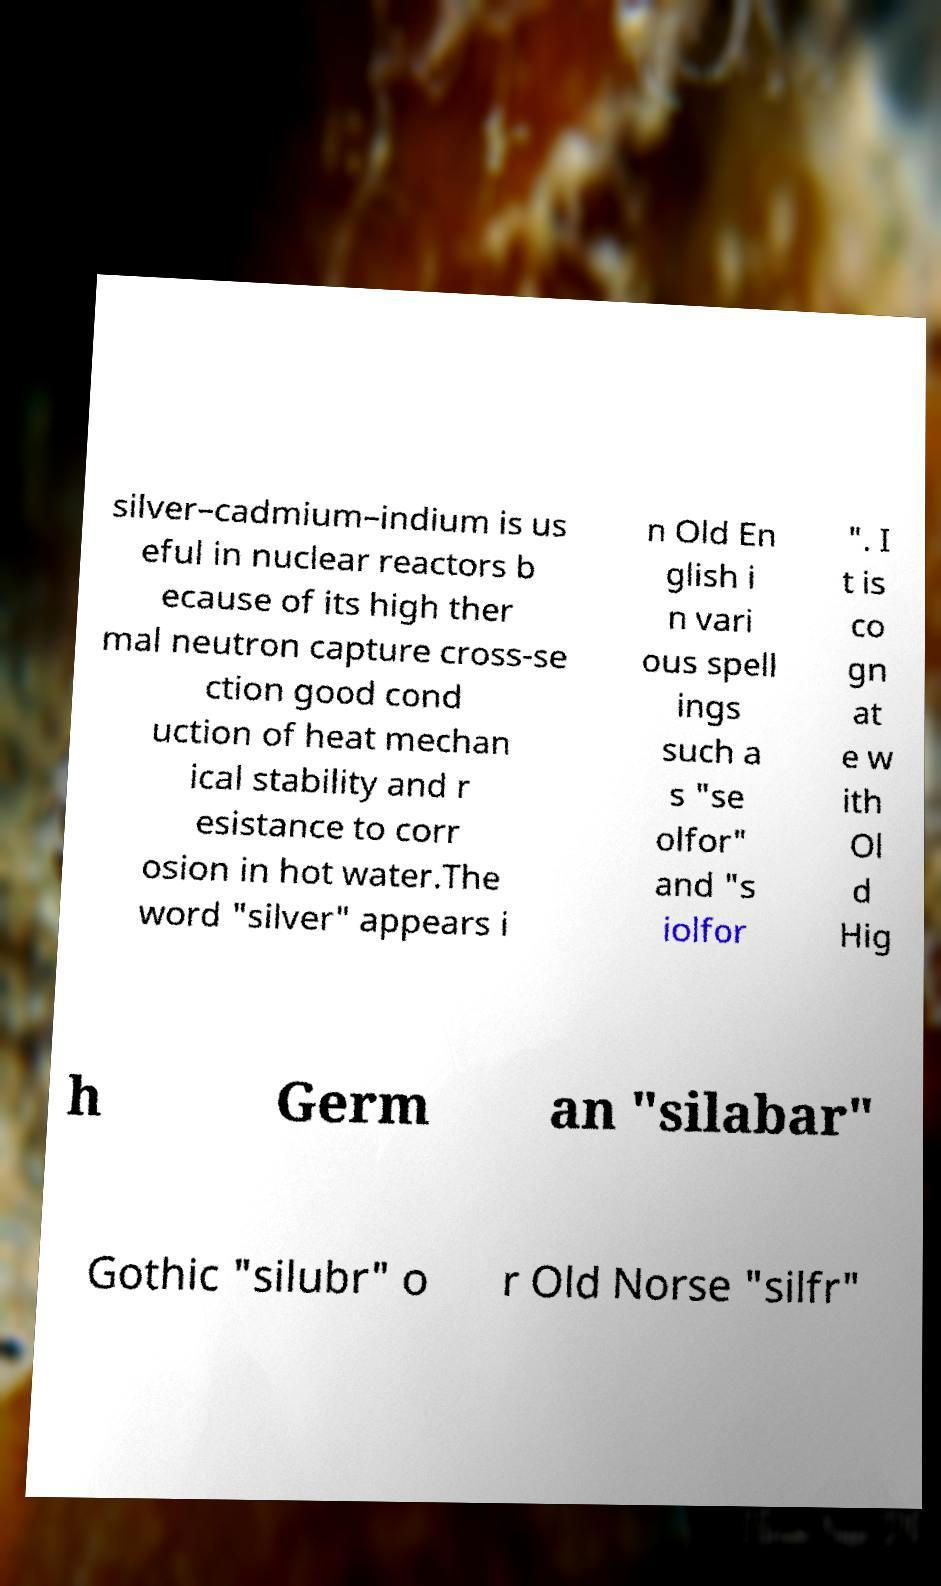Can you read and provide the text displayed in the image?This photo seems to have some interesting text. Can you extract and type it out for me? silver–cadmium–indium is us eful in nuclear reactors b ecause of its high ther mal neutron capture cross-se ction good cond uction of heat mechan ical stability and r esistance to corr osion in hot water.The word "silver" appears i n Old En glish i n vari ous spell ings such a s "se olfor" and "s iolfor ". I t is co gn at e w ith Ol d Hig h Germ an "silabar" Gothic "silubr" o r Old Norse "silfr" 